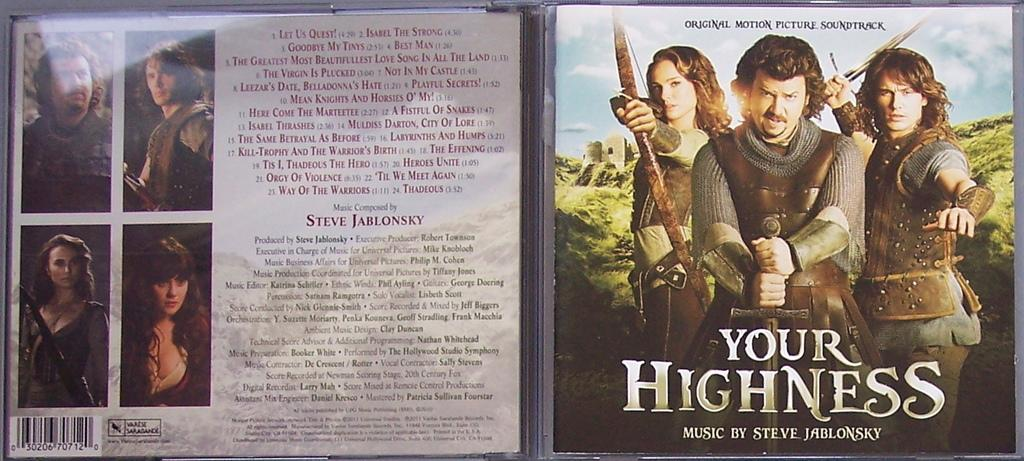Provide a one-sentence caption for the provided image. a cd cover for 'your highness' music by steve jablonsky. 